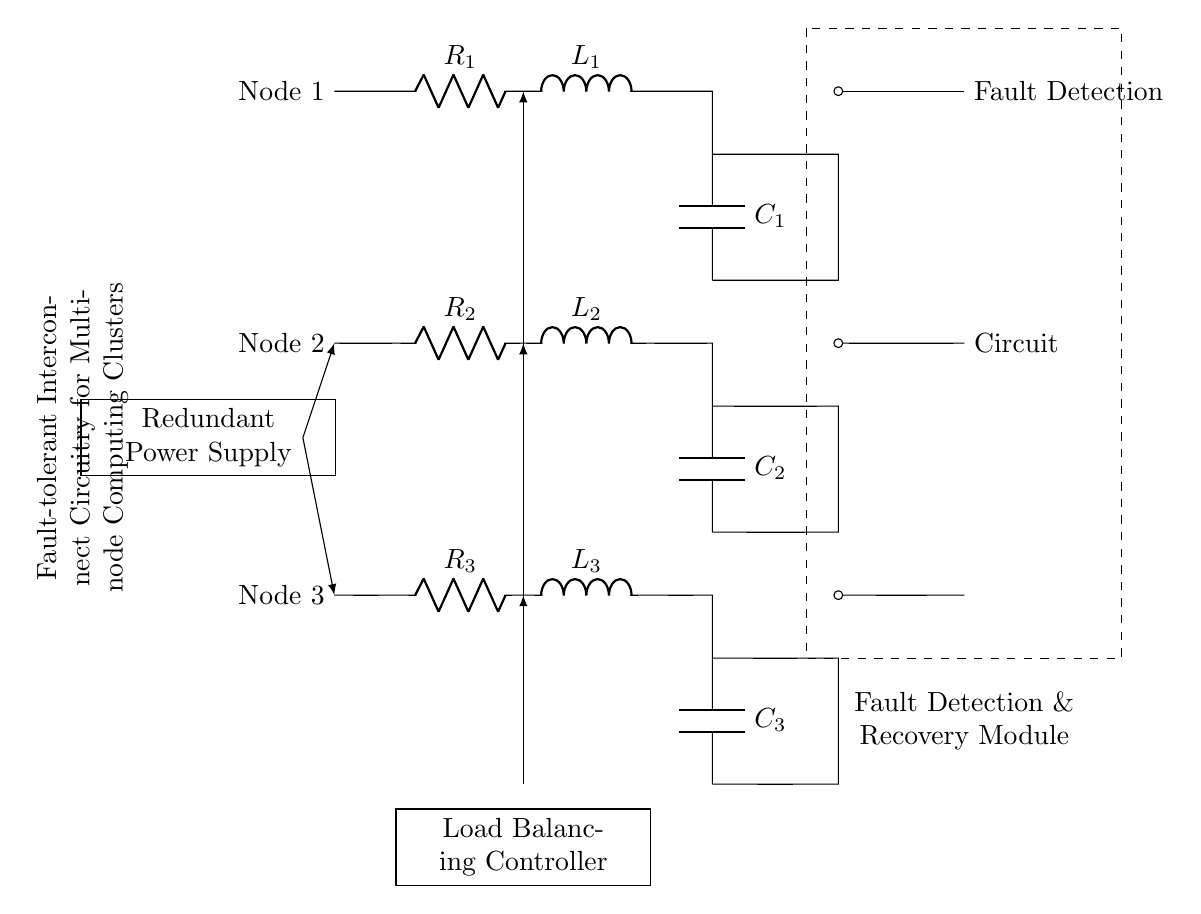What are the three nodes in the circuit? The circuit has Node 1, Node 2, and Node 3, as labeled on the left side of the diagram. Each node is indicated with corresponding components linked to it.
Answer: Node 1, Node 2, Node 3 What is the function of the Fault Detection & Recovery Module? This module is responsible for detecting faults in the circuit and facilitating recovery mechanisms. It is isolated from the nodes and has connections leading to them for monitoring purposes.
Answer: Monitoring and recovery How many resistors are there in the circuit? The circuit diagram depicts three resistors: R1, R2, and R3, which are connected to their respective nodes. This can be inferred from the labels seen on the diagram.
Answer: Three What component connects all three nodes to a redundant power supply? The diagram shows a redundant power supply connected to all nodes via short connections that branch off to each node representation.
Answer: Redundant Power Supply Which component delivers a load balancing function in the circuit? The Load Balancing Controller appears under the circuit with arrows indicating connections to each node, suggesting its role in distributing load among nodes.
Answer: Load Balancing Controller How is the Fault Detection connected to the nodes? The Fault Detection module has a direct connection to each of the nodes through short circuits, indicating a continuous monitoring capability for fault conditions across the nodes.
Answer: Directly through short circuits What does the dashed rectangle represent in the circuit? The dashed rectangle encompasses the Fault Detection & Recovery Module, indicating that it is a boxed section of the circuit dedicated to this specific functionality.
Answer: Fault Detection & Recovery Module 